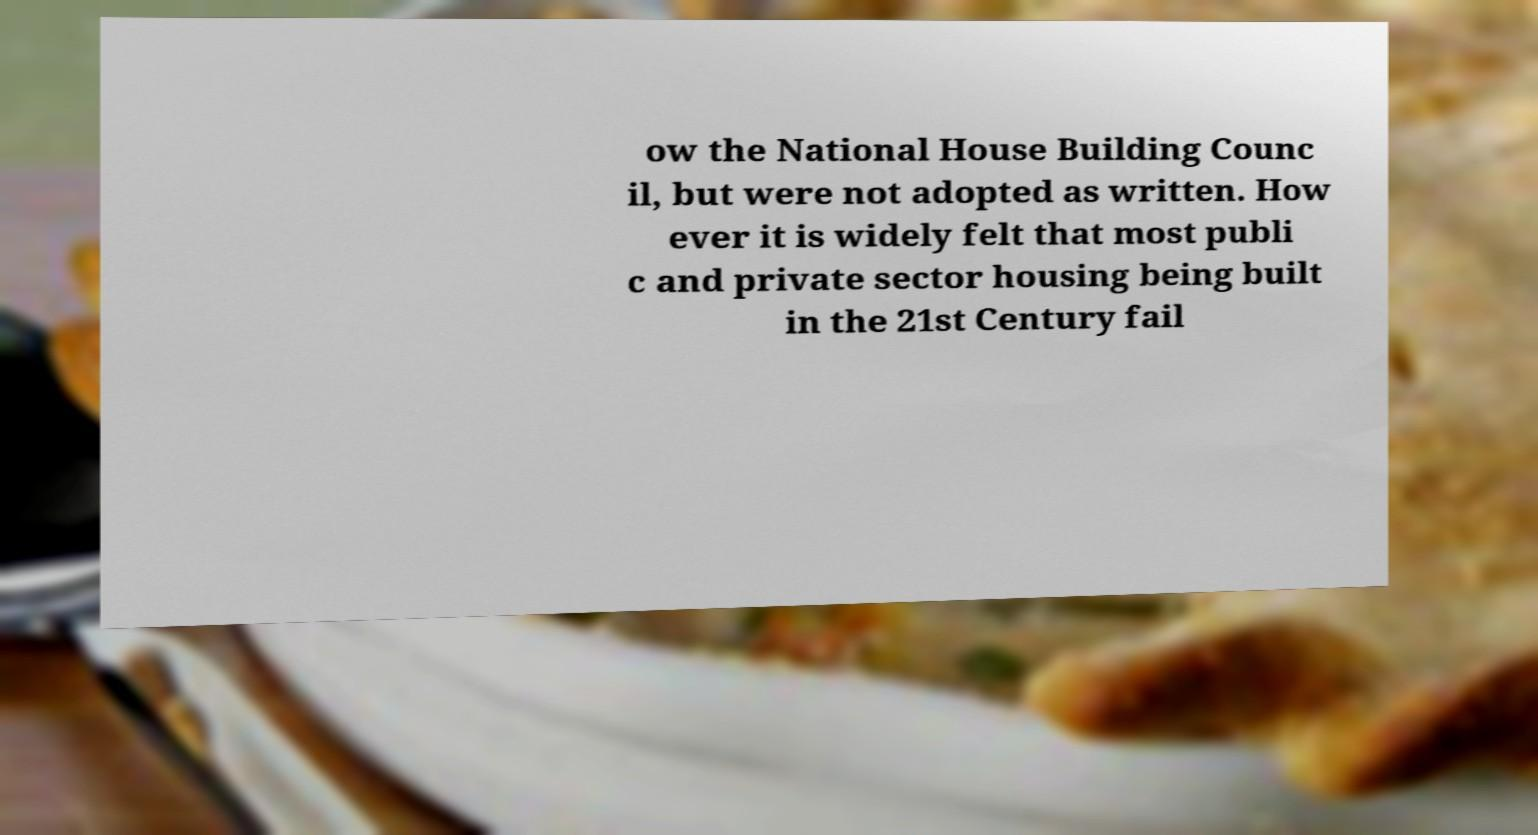Can you accurately transcribe the text from the provided image for me? ow the National House Building Counc il, but were not adopted as written. How ever it is widely felt that most publi c and private sector housing being built in the 21st Century fail 